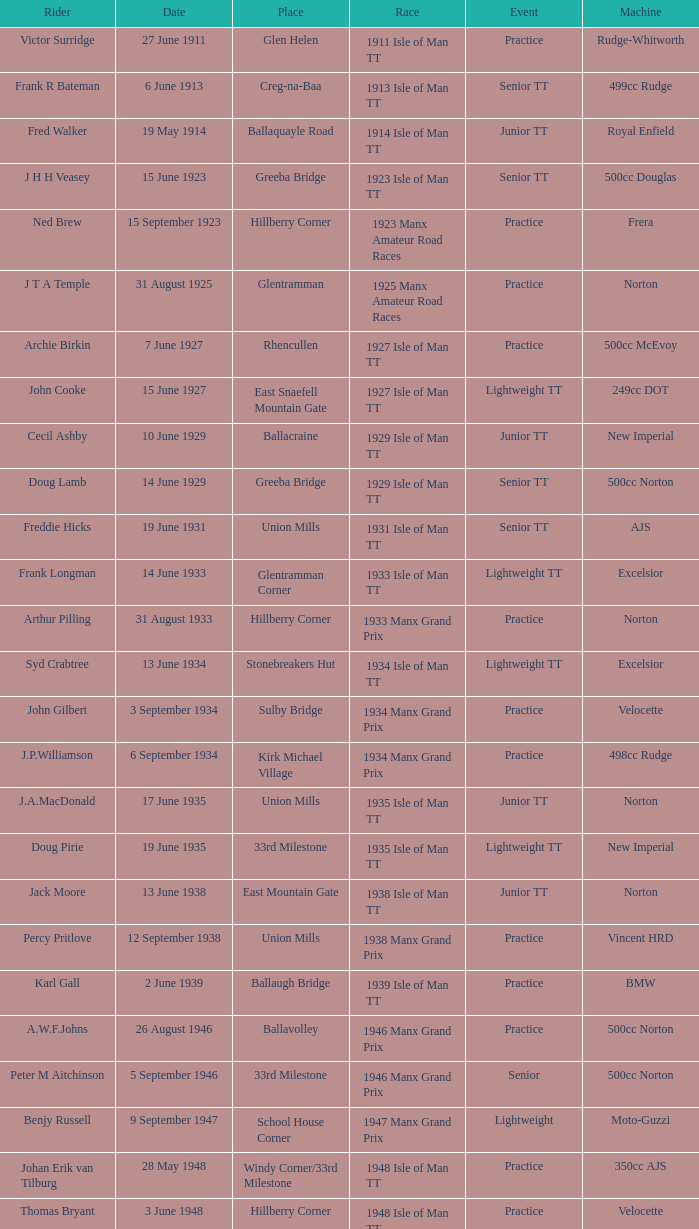Which device was ridden by keith t. gawler? 499cc Norton. 